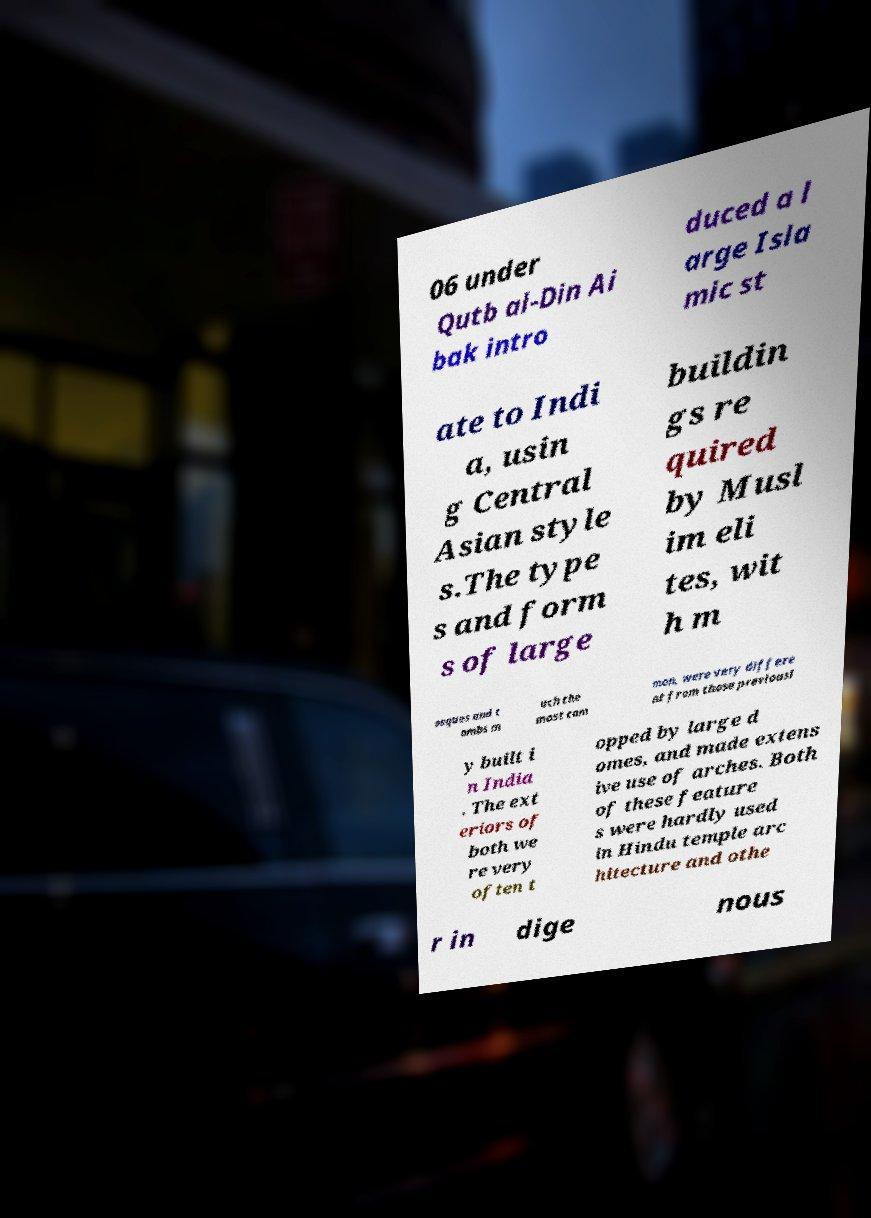Could you extract and type out the text from this image? 06 under Qutb al-Din Ai bak intro duced a l arge Isla mic st ate to Indi a, usin g Central Asian style s.The type s and form s of large buildin gs re quired by Musl im eli tes, wit h m osques and t ombs m uch the most com mon, were very differe nt from those previousl y built i n India . The ext eriors of both we re very often t opped by large d omes, and made extens ive use of arches. Both of these feature s were hardly used in Hindu temple arc hitecture and othe r in dige nous 